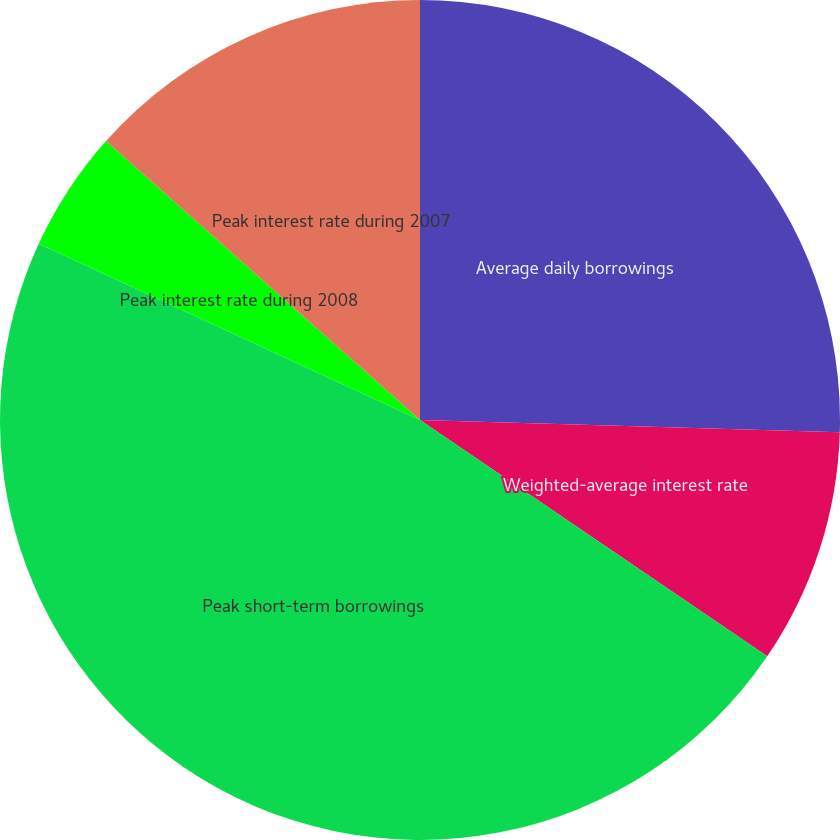Convert chart. <chart><loc_0><loc_0><loc_500><loc_500><pie_chart><fcel>Average daily borrowings<fcel>Weighted-average interest rate<fcel>Peak short-term borrowings<fcel>Peak interest rate during 2008<fcel>Peak interest rate during 2007<nl><fcel>25.46%<fcel>9.05%<fcel>47.38%<fcel>4.67%<fcel>13.44%<nl></chart> 